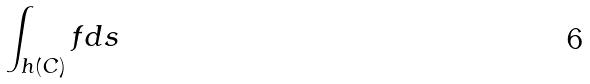Convert formula to latex. <formula><loc_0><loc_0><loc_500><loc_500>\int _ { h ( C ) } f d s</formula> 